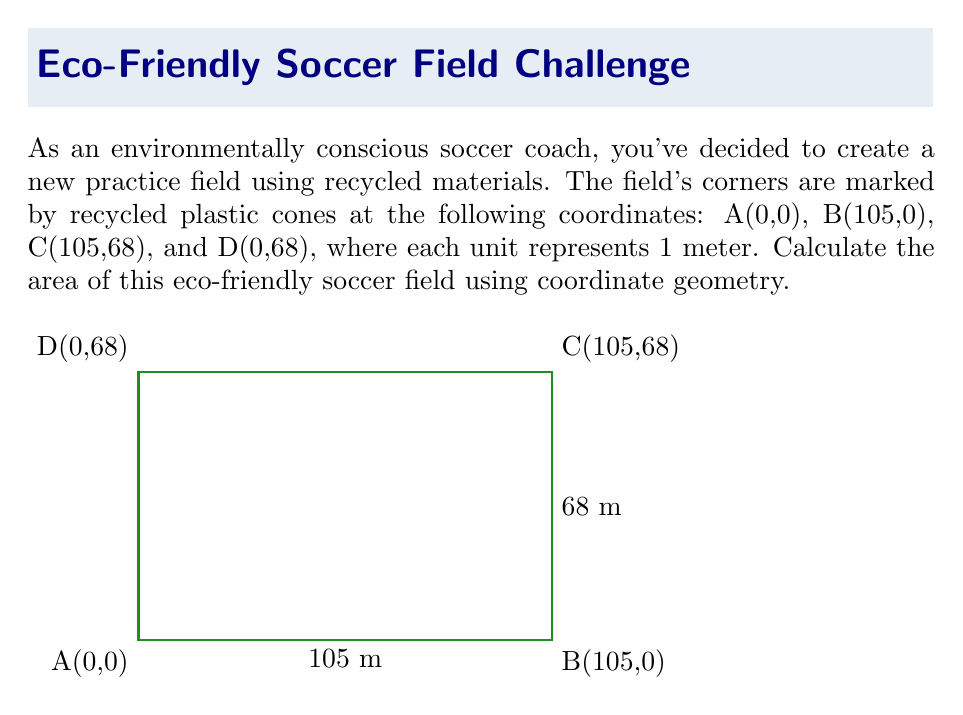Can you solve this math problem? To calculate the area of the soccer field using coordinate geometry, we can use the formula for the area of a polygon given the coordinates of its vertices. For a quadrilateral, the formula is:

$$ \text{Area} = \frac{1}{2}|(x_1y_2 + x_2y_3 + x_3y_4 + x_4y_1) - (y_1x_2 + y_2x_3 + y_3x_4 + y_4x_1)| $$

Where $(x_1,y_1)$, $(x_2,y_2)$, $(x_3,y_3)$, and $(x_4,y_4)$ are the coordinates of the four vertices.

Let's substitute the given coordinates:
A(0,0), B(105,0), C(105,68), D(0,68)

$$ \text{Area} = \frac{1}{2}|(0 \cdot 0 + 105 \cdot 68 + 105 \cdot 68 + 0 \cdot 0) - (0 \cdot 105 + 0 \cdot 105 + 68 \cdot 0 + 68 \cdot 0)| $$

Simplifying:
$$ \text{Area} = \frac{1}{2}|(0 + 7140 + 7140 + 0) - (0 + 0 + 0 + 0)| $$
$$ \text{Area} = \frac{1}{2}|14280 - 0| $$
$$ \text{Area} = \frac{1}{2} \cdot 14280 $$
$$ \text{Area} = 7140 $$

Therefore, the area of the eco-friendly soccer field is 7140 square meters.
Answer: 7140 m² 